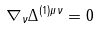Convert formula to latex. <formula><loc_0><loc_0><loc_500><loc_500>\nabla _ { \nu } \Delta ^ { ( 1 ) \mu \nu } = 0</formula> 